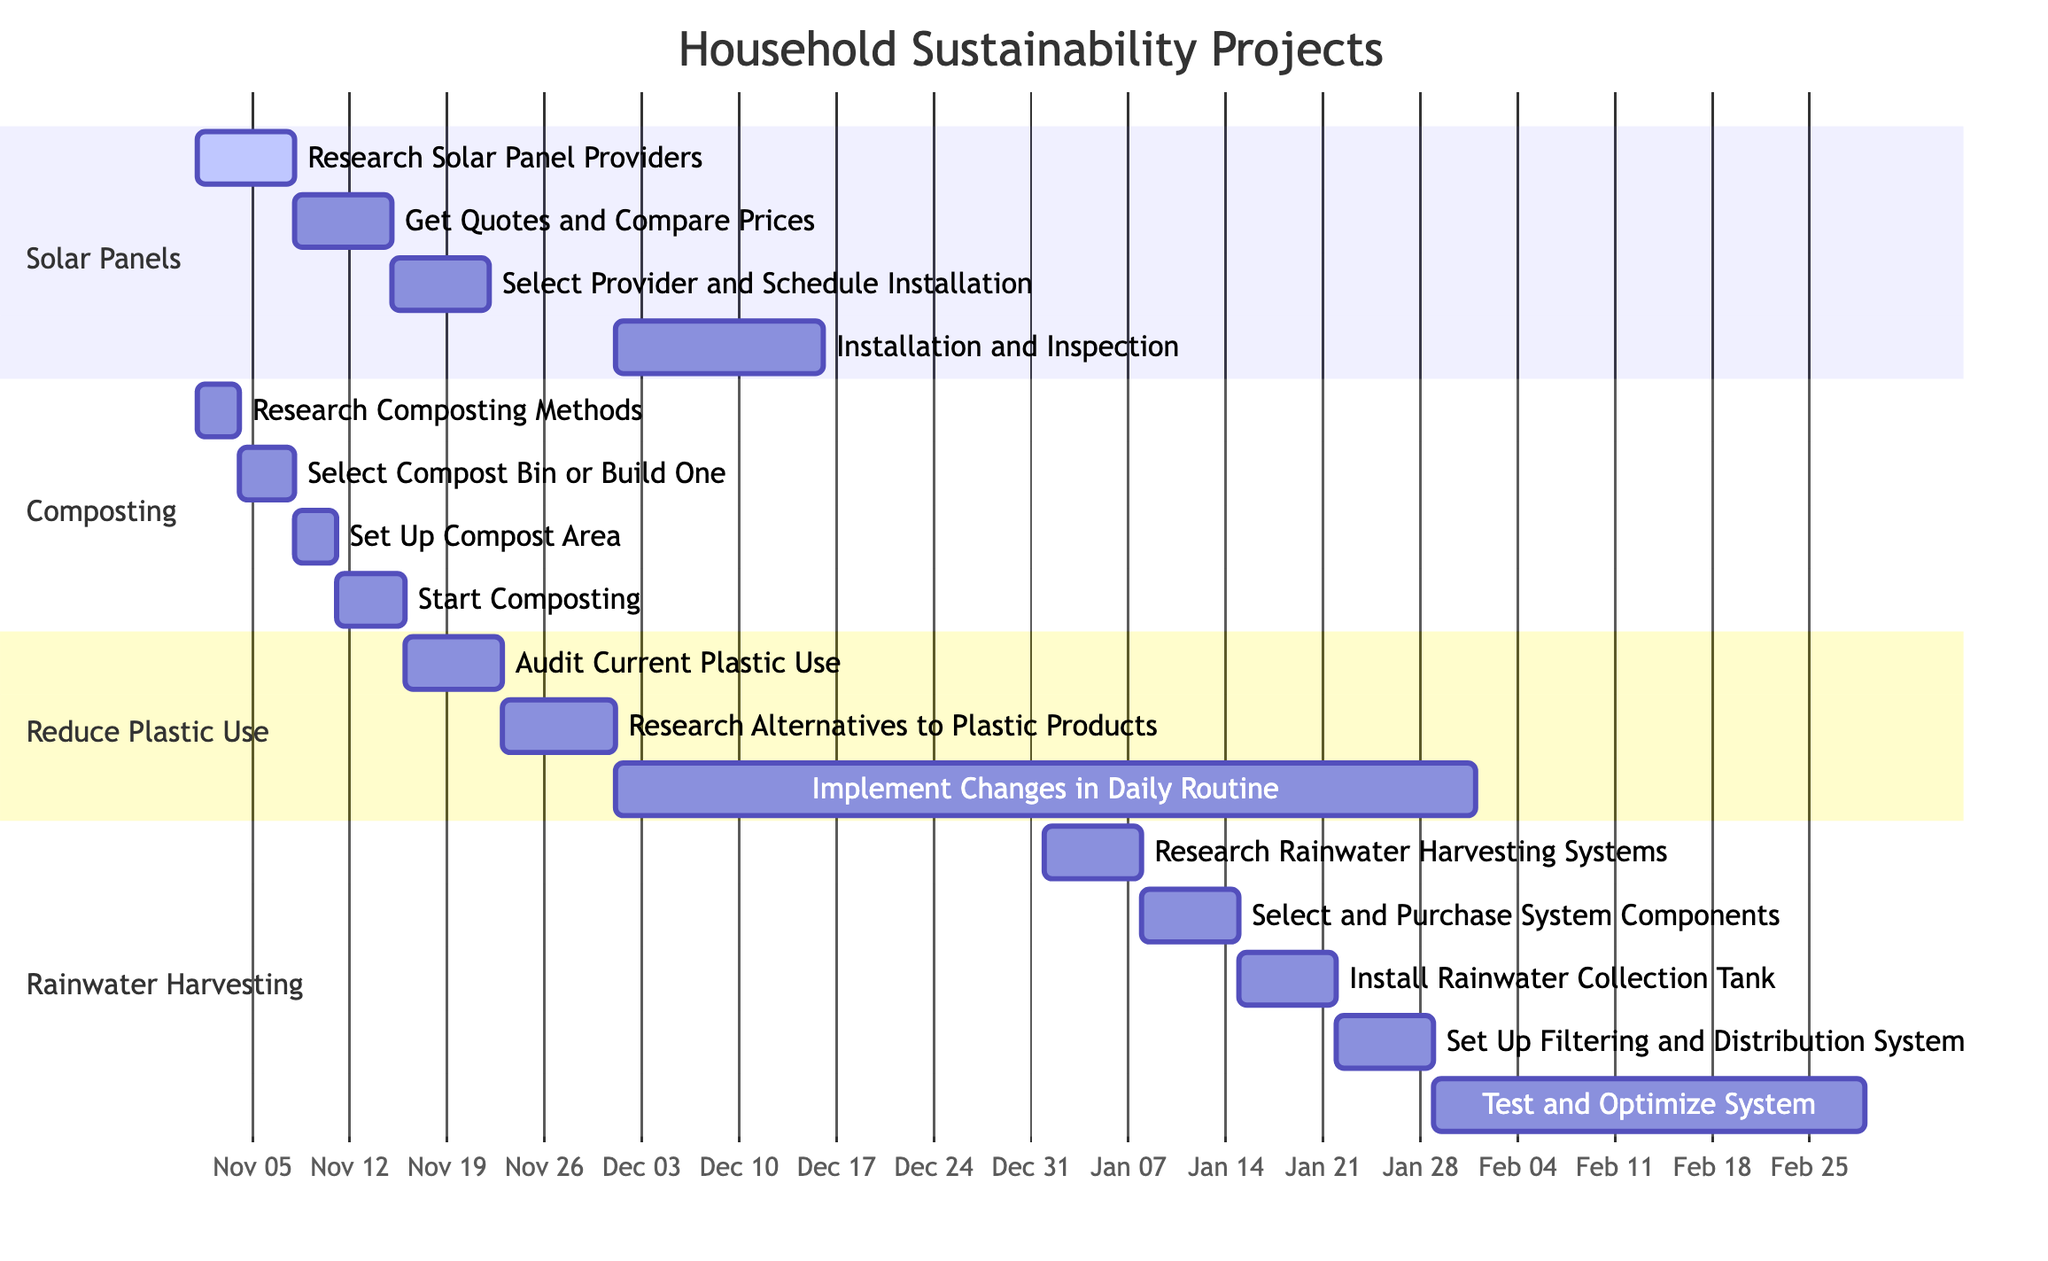What is the duration of the "Install Solar Panels" project? The "Install Solar Panels" project starts on November 1, 2023, and ends on December 15, 2023. Calculating the duration, we see it's from November 1 to December 15, which is 45 days in total.
Answer: 45 days When does the "Start Composting" step begin? In the "Composting Setup" project, the "Start Composting" step starts on November 11, 2023. This is specified by the designated start date for that task in the diagram.
Answer: November 11, 2023 How many steps are involved in setting up the rainwater harvesting system? The "Set Up Rainwater Harvesting System" consists of five distinct steps as shown in the diagram. These steps include research, selection, installation, setup, and testing. Therefore, the total count of steps is five.
Answer: 5 What task overlaps with the "Implement Changes in Daily Routine" step? The "Implement Changes in Daily Routine" overlaps with "Installation and Inspection" of the "Install Solar Panels" project, as both tasks occur simultaneously, particularly from December 1, 2023, to January 31, 2024.
Answer: Installation and Inspection Which project has the shortest completion time? Among all the listed projects, the "Composting Setup" has the shortest completion time. It starts on November 1, 2023, and ends on November 15, 2023, totaling just 15 days.
Answer: Composting Setup What is the final date for testing the rainwater harvesting system? The "Test and Optimize System" step for the rainwater harvesting system ends on February 28, 2024. This step is the last one in the timeline for that project, clearly marked in the diagram.
Answer: February 28, 2024 What is the primary goal of the "Reduce Plastic Use" project? The primary goal is to significantly decrease or eliminate the use of plastic products in daily life. This is articulated through the steps outlined, which include auditing current use and researching alternatives.
Answer: Decrease plastic use When does the "Research Alternatives to Plastic Products" step start? The "Research Alternatives to Plastic Products" step starts on November 23, 2023. This is evident from the start date assigned to that specific task in the project timeline.
Answer: November 23, 2023 